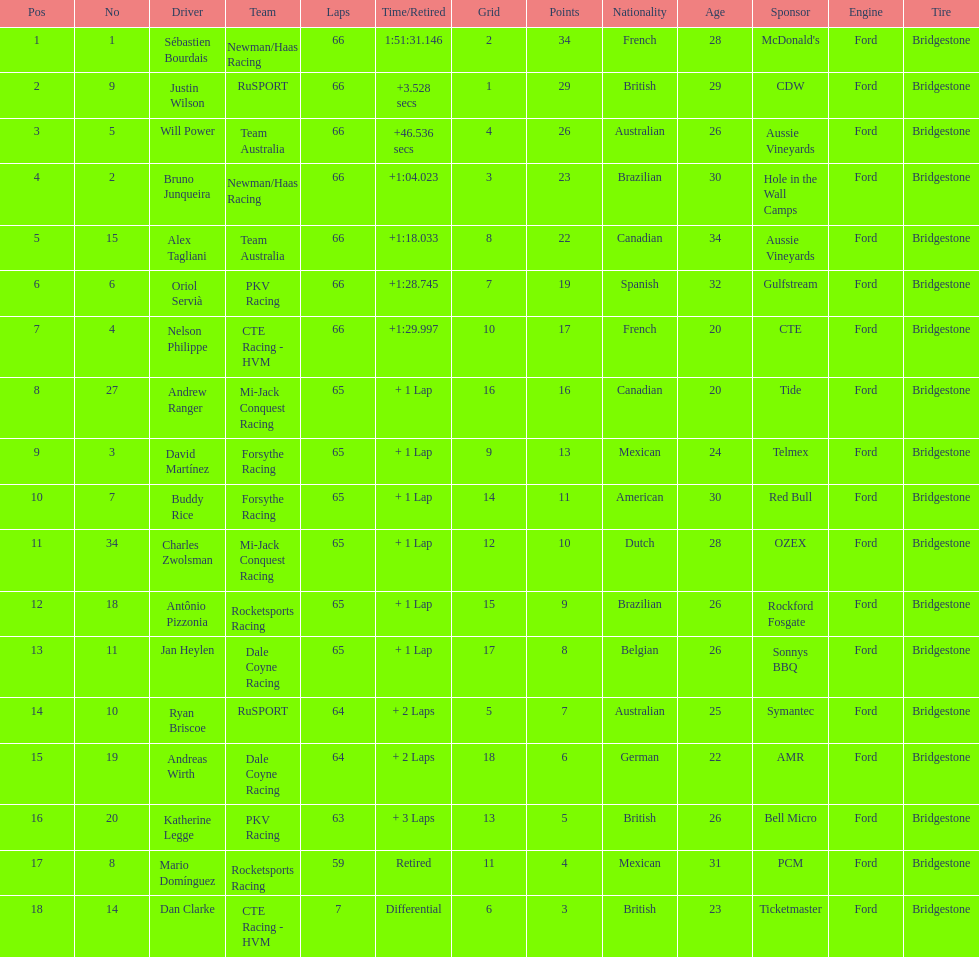Between oriol servia and katherine legge, who managed to complete more laps at the 2006 gran premio telmex? Oriol Servià. 